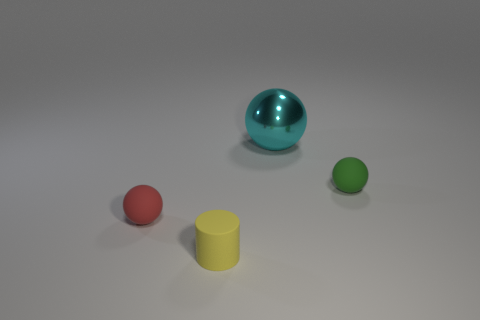There is a tiny red ball; are there any small yellow cylinders in front of it?
Provide a succinct answer. Yes. Do the yellow rubber thing and the red matte ball have the same size?
Your answer should be compact. Yes. There is a green matte thing that is the same shape as the red thing; what is its size?
Provide a short and direct response. Small. Are there any other things that are the same size as the metallic object?
Provide a succinct answer. No. There is a thing in front of the small ball in front of the small green sphere; what is it made of?
Make the answer very short. Rubber. Do the large thing and the tiny green object have the same shape?
Provide a short and direct response. Yes. How many tiny spheres are both behind the red thing and in front of the tiny green ball?
Your response must be concise. 0. Are there an equal number of small red rubber balls to the right of the yellow matte thing and spheres to the left of the green rubber thing?
Your answer should be very brief. No. There is a rubber ball left of the large cyan sphere; is it the same size as the rubber ball to the right of the large metallic sphere?
Your response must be concise. Yes. The ball that is both left of the tiny green matte thing and right of the yellow matte cylinder is made of what material?
Your response must be concise. Metal. 